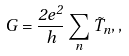Convert formula to latex. <formula><loc_0><loc_0><loc_500><loc_500>G = \frac { 2 e ^ { 2 } } { h } \sum _ { n } \tilde { T } _ { n } , ,</formula> 